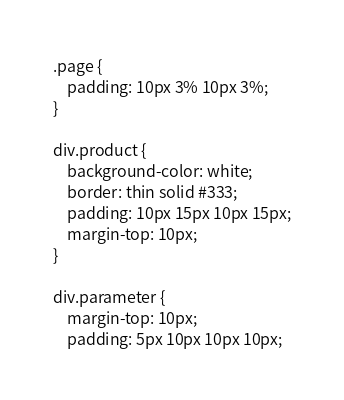<code> <loc_0><loc_0><loc_500><loc_500><_HTML_>.page {
	padding: 10px 3% 10px 3%;
}

div.product {
	background-color: white;
	border: thin solid #333;
	padding: 10px 15px 10px 15px;
	margin-top: 10px;
}

div.parameter {
	margin-top: 10px;
	padding: 5px 10px 10px 10px;</code> 